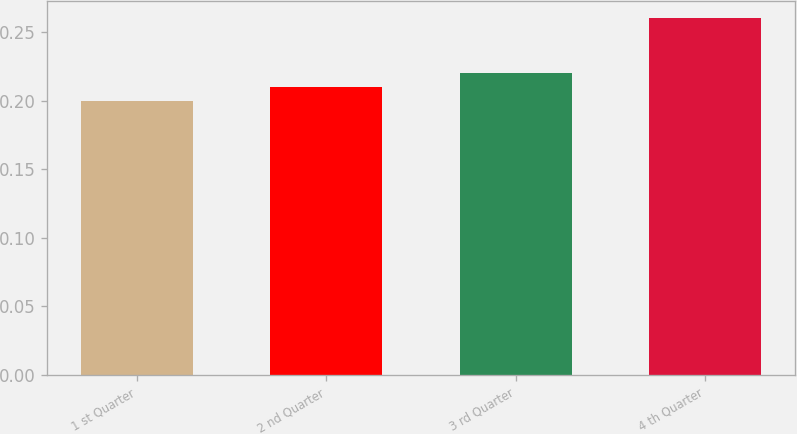Convert chart to OTSL. <chart><loc_0><loc_0><loc_500><loc_500><bar_chart><fcel>1 st Quarter<fcel>2 nd Quarter<fcel>3 rd Quarter<fcel>4 th Quarter<nl><fcel>0.2<fcel>0.21<fcel>0.22<fcel>0.26<nl></chart> 